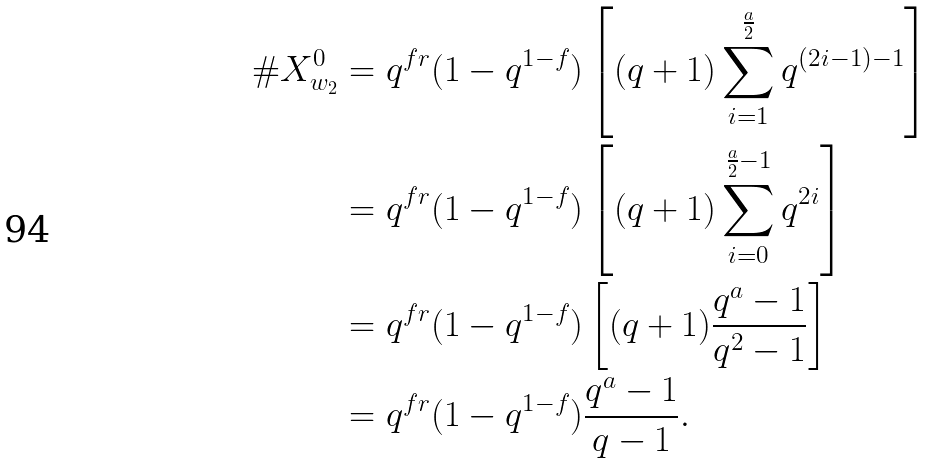Convert formula to latex. <formula><loc_0><loc_0><loc_500><loc_500>\# X ^ { 0 } _ { w _ { 2 } } & = q ^ { f r } ( 1 - q ^ { 1 - f } ) \left [ ( q + 1 ) \sum _ { i = 1 } ^ { \frac { a } { 2 } } q ^ { ( 2 i - 1 ) - 1 } \right ] \\ & = q ^ { f r } ( 1 - q ^ { 1 - f } ) \left [ ( q + 1 ) \sum _ { i = 0 } ^ { \frac { a } { 2 } - 1 } q ^ { 2 i } \right ] \\ & = q ^ { f r } ( 1 - q ^ { 1 - f } ) \left [ ( q + 1 ) \frac { q ^ { a } - 1 } { q ^ { 2 } - 1 } \right ] \\ & = q ^ { f r } ( 1 - q ^ { 1 - f } ) \frac { q ^ { a } - 1 } { q - 1 } .</formula> 